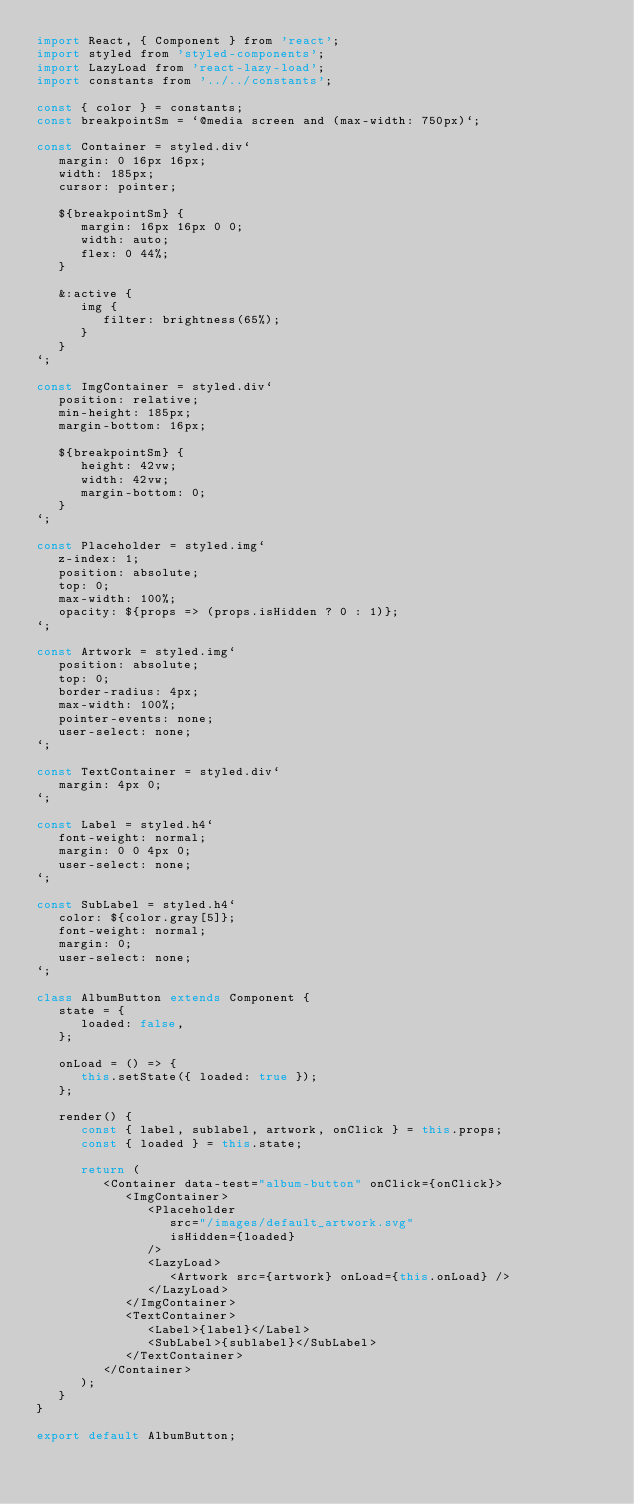Convert code to text. <code><loc_0><loc_0><loc_500><loc_500><_JavaScript_>import React, { Component } from 'react';
import styled from 'styled-components';
import LazyLoad from 'react-lazy-load';
import constants from '../../constants';

const { color } = constants;
const breakpointSm = `@media screen and (max-width: 750px)`;

const Container = styled.div`
   margin: 0 16px 16px;
   width: 185px;
   cursor: pointer;

   ${breakpointSm} {
      margin: 16px 16px 0 0;
      width: auto;
      flex: 0 44%;
   }

   &:active {
      img {
         filter: brightness(65%);
      }
   }
`;

const ImgContainer = styled.div`
   position: relative;
   min-height: 185px;
   margin-bottom: 16px;

   ${breakpointSm} {
      height: 42vw;
      width: 42vw;
      margin-bottom: 0;
   }
`;

const Placeholder = styled.img`
   z-index: 1;
   position: absolute;
   top: 0;
   max-width: 100%;
   opacity: ${props => (props.isHidden ? 0 : 1)};
`;

const Artwork = styled.img`
   position: absolute;
   top: 0;
   border-radius: 4px;
   max-width: 100%;
   pointer-events: none;
   user-select: none;
`;

const TextContainer = styled.div`
   margin: 4px 0;
`;

const Label = styled.h4`
   font-weight: normal;
   margin: 0 0 4px 0;
   user-select: none;
`;

const SubLabel = styled.h4`
   color: ${color.gray[5]};
   font-weight: normal;
   margin: 0;
   user-select: none;
`;

class AlbumButton extends Component {
   state = {
      loaded: false,
   };

   onLoad = () => {
      this.setState({ loaded: true });
   };

   render() {
      const { label, sublabel, artwork, onClick } = this.props;
      const { loaded } = this.state;

      return (
         <Container data-test="album-button" onClick={onClick}>
            <ImgContainer>
               <Placeholder
                  src="/images/default_artwork.svg"
                  isHidden={loaded}
               />
               <LazyLoad>
                  <Artwork src={artwork} onLoad={this.onLoad} />
               </LazyLoad>
            </ImgContainer>
            <TextContainer>
               <Label>{label}</Label>
               <SubLabel>{sublabel}</SubLabel>
            </TextContainer>
         </Container>
      );
   }
}

export default AlbumButton;
</code> 